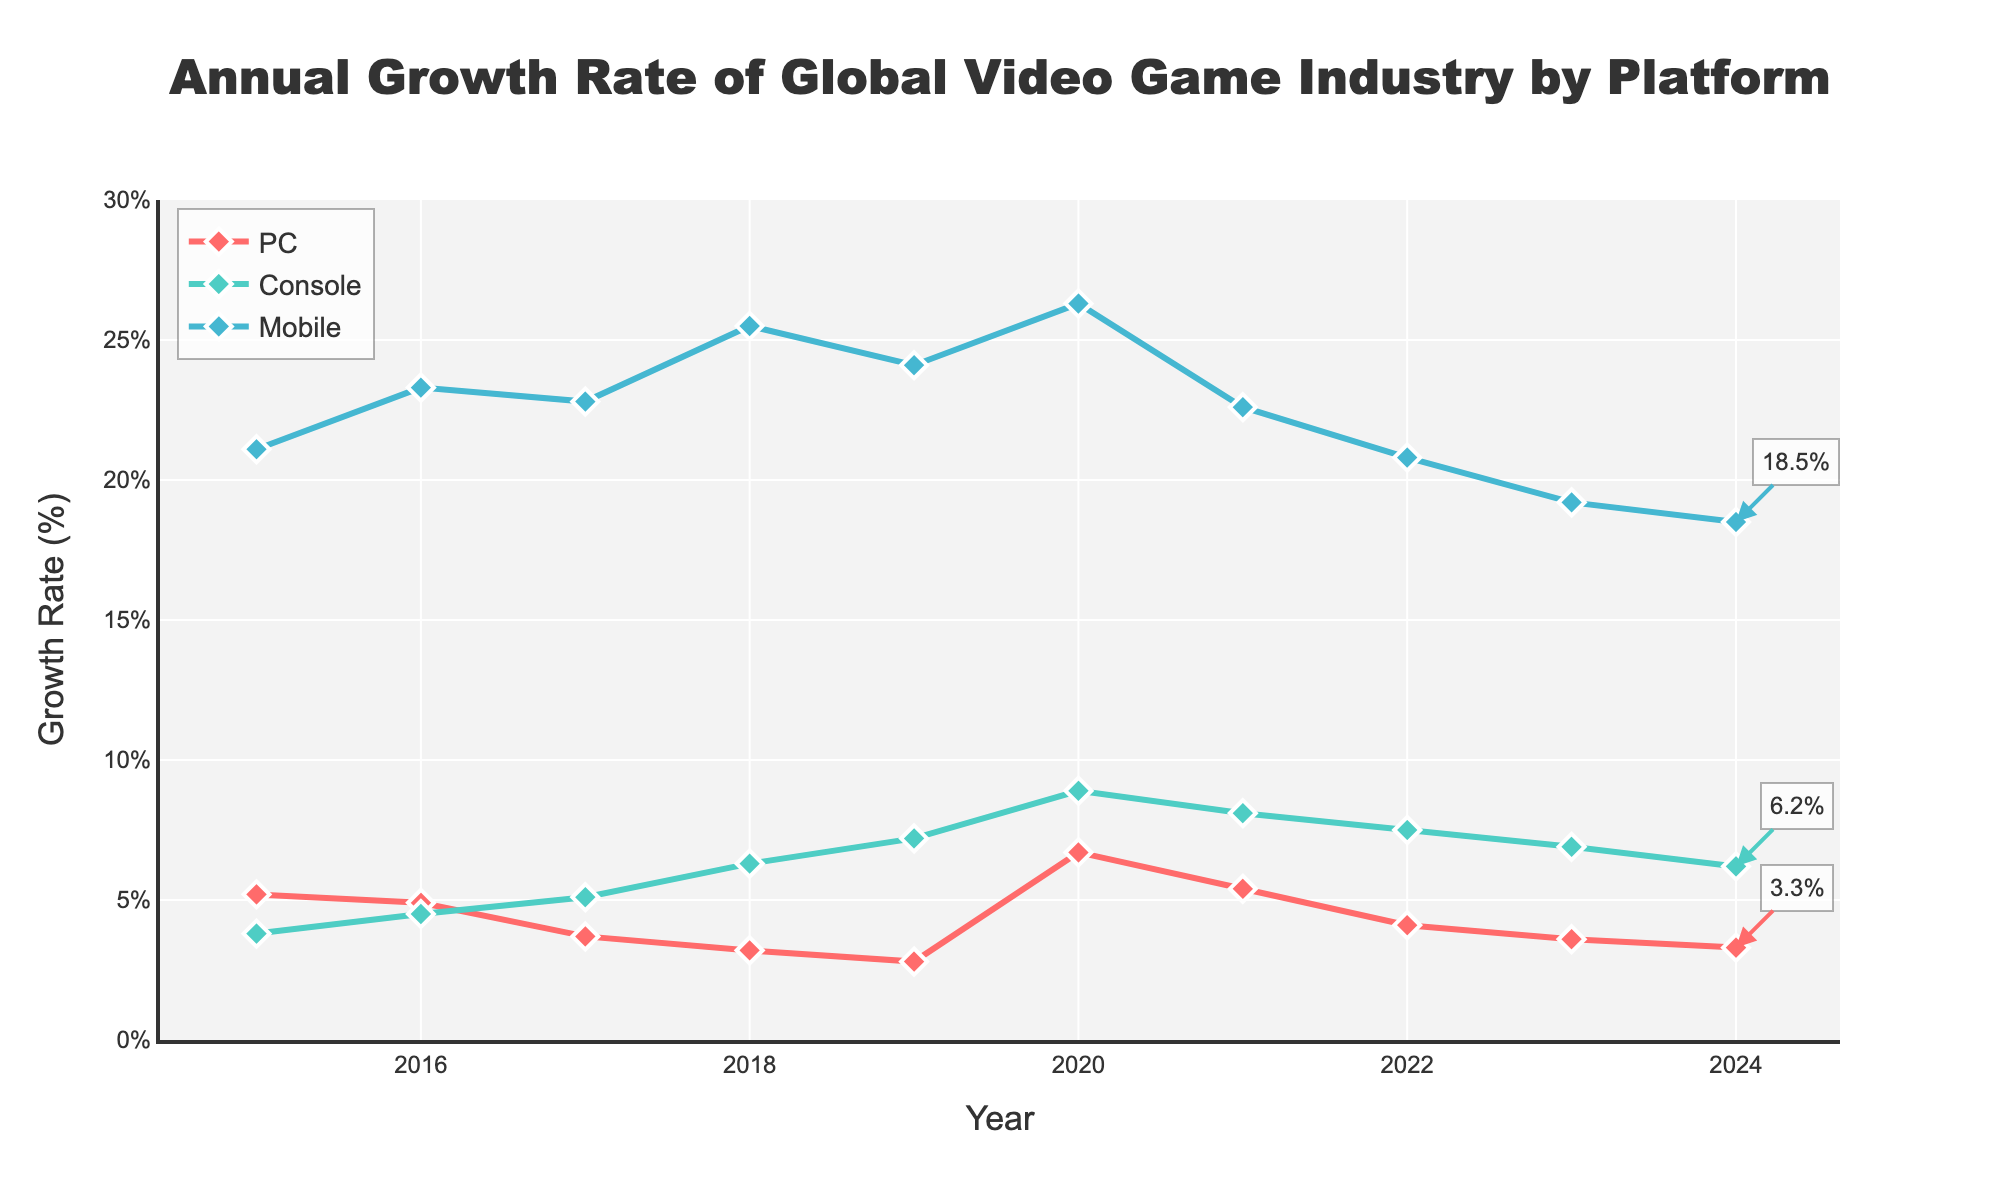What's the growth rate of mobile gaming in 2015? Locate the 'Mobile' line on the plot and find the data point corresponding to 2015. The value is 21.1%.
Answer: 21.1% Which platform had the highest growth rate in 2020? Compare the three lines (PC, Console, Mobile) at the 2020 data point. Console has the highest value, 8.9%.
Answer: Console Between 2021 and 2022, which platform saw the largest decrease in growth rate? Calculate the differences: PC (5.4 - 4.1 = 1.3), Console (8.1 - 7.5 = 0.6), Mobile (22.6 - 20.8 = 1.8). Mobile has the largest decrease.
Answer: Mobile What is the average growth rate for console gaming from 2015 to 2024? Sum all growth rates for Console from 2015 to 2024 and divide by the number of years (10). Sum = 64.5, average = 64.5 / 10 = 6.45%
Answer: 6.45% Which platform has the most stable growth rate (less fluctuation) over the years? Visually observe the smoothness of the lines; the PC line shows the least fluctuation.
Answer: PC In which year did PC gaming experience its highest growth rate? Find the maximum point on the PC line. The highest value, 6.7%, occurred in 2020.
Answer: 2020 How much did mobile gaming's growth rate decrease from its peak in 2018 to 2024? The peak growth rate for Mobile was 25.5% in 2018, and the value in 2024 is 18.5%. Difference = 25.5 - 18.5 = 7%.
Answer: 7% What is the trend of console gaming’s growth rate from 2015 to 2024? Observe the overall direction of the Console line from 2015 to 2024. The growth rate increases, peaking around 2020-2021, then gradually decreases.
Answer: Increasing then decreasing Which year had the lowest growth rate for PC gaming? Find the minimum point on the PC line. The lowest value, 2.8%, occurred in 2019.
Answer: 2019 